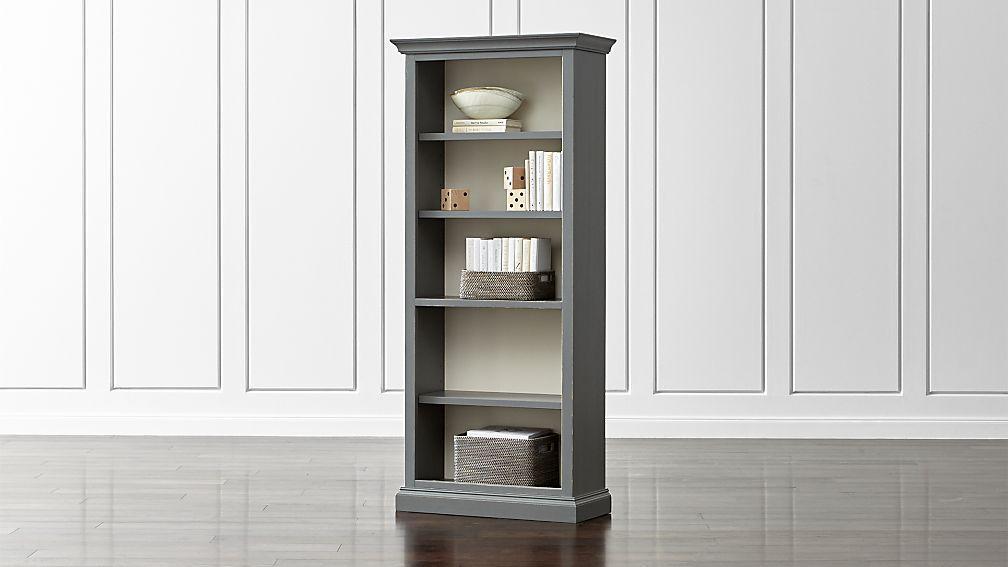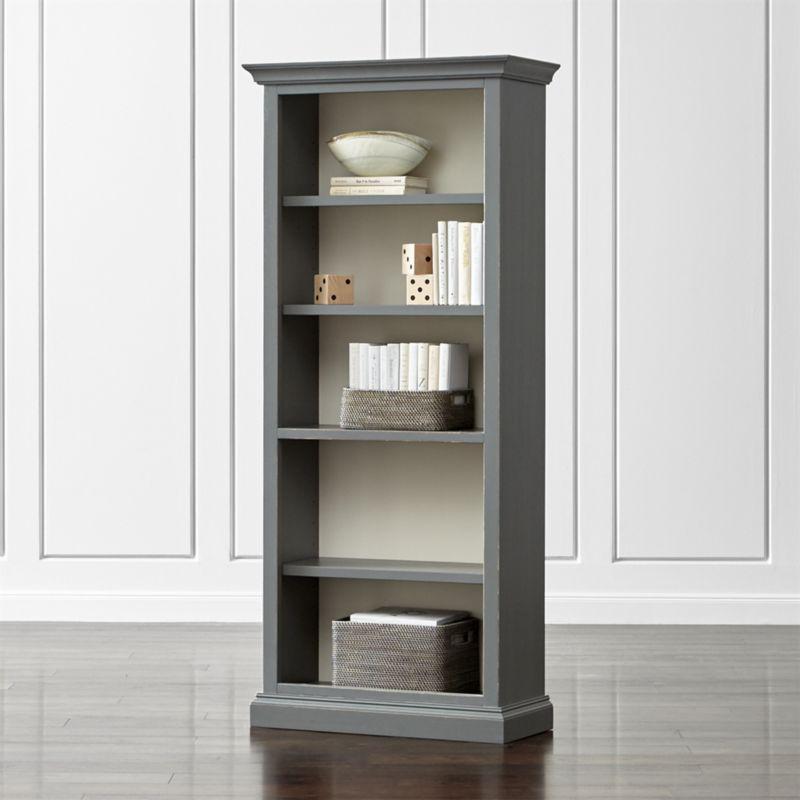The first image is the image on the left, the second image is the image on the right. Considering the images on both sides, is "At least one tall, narrow bookcase has closed double doors at the bottom." valid? Answer yes or no. No. 